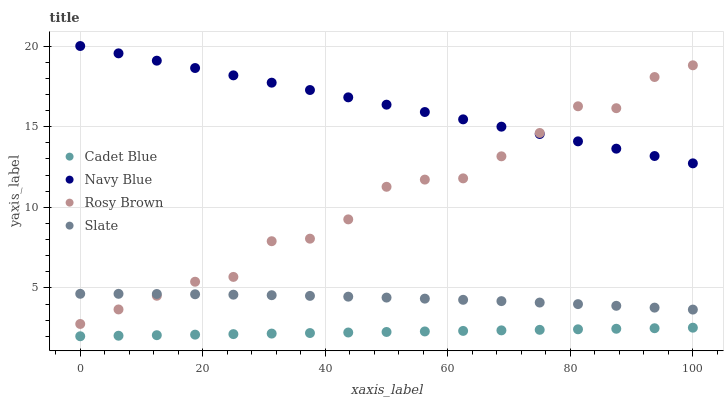Does Cadet Blue have the minimum area under the curve?
Answer yes or no. Yes. Does Navy Blue have the maximum area under the curve?
Answer yes or no. Yes. Does Rosy Brown have the minimum area under the curve?
Answer yes or no. No. Does Rosy Brown have the maximum area under the curve?
Answer yes or no. No. Is Cadet Blue the smoothest?
Answer yes or no. Yes. Is Rosy Brown the roughest?
Answer yes or no. Yes. Is Rosy Brown the smoothest?
Answer yes or no. No. Is Cadet Blue the roughest?
Answer yes or no. No. Does Cadet Blue have the lowest value?
Answer yes or no. Yes. Does Rosy Brown have the lowest value?
Answer yes or no. No. Does Navy Blue have the highest value?
Answer yes or no. Yes. Does Rosy Brown have the highest value?
Answer yes or no. No. Is Slate less than Navy Blue?
Answer yes or no. Yes. Is Navy Blue greater than Slate?
Answer yes or no. Yes. Does Rosy Brown intersect Slate?
Answer yes or no. Yes. Is Rosy Brown less than Slate?
Answer yes or no. No. Is Rosy Brown greater than Slate?
Answer yes or no. No. Does Slate intersect Navy Blue?
Answer yes or no. No. 